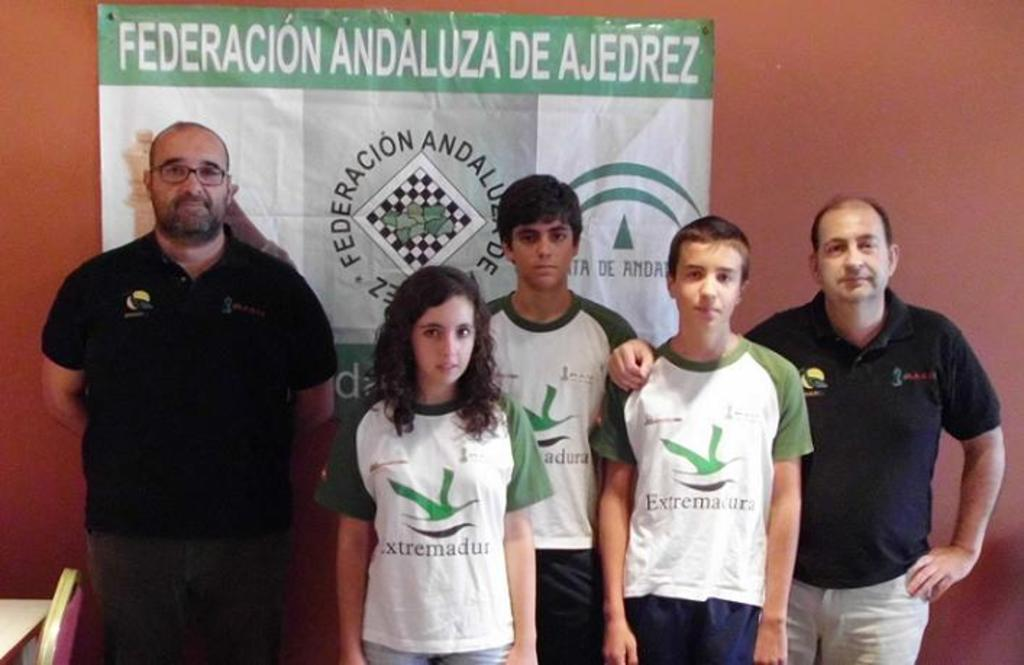<image>
Give a short and clear explanation of the subsequent image. A group of people standing in front of a banner that says Federacion Andaluza De Ajedrez. 